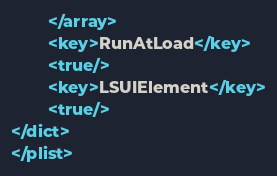<code> <loc_0><loc_0><loc_500><loc_500><_XML_>        </array>
        <key>RunAtLoad</key>
        <true/>
        <key>LSUIElement</key>
		<true/>
</dict>
</plist>
</code> 